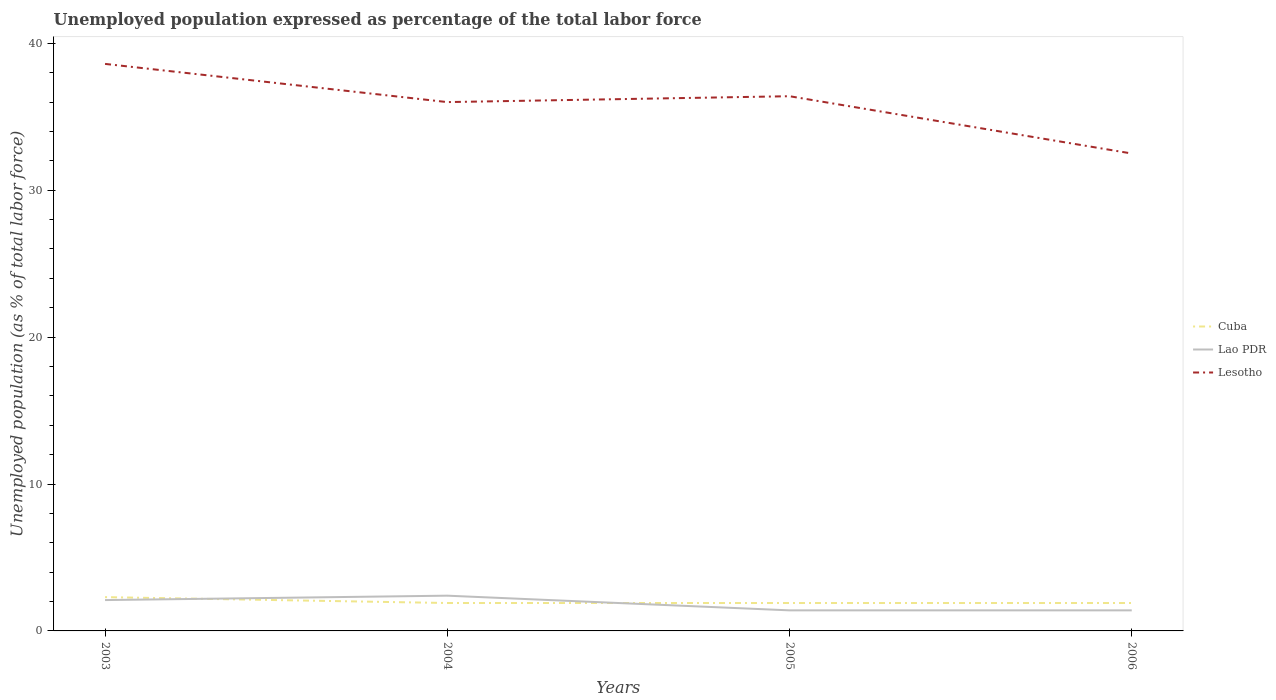Does the line corresponding to Lao PDR intersect with the line corresponding to Cuba?
Keep it short and to the point. Yes. Is the number of lines equal to the number of legend labels?
Offer a very short reply. Yes. Across all years, what is the maximum unemployment in in Cuba?
Offer a very short reply. 1.9. What is the total unemployment in in Cuba in the graph?
Provide a succinct answer. 0.4. What is the difference between the highest and the second highest unemployment in in Lao PDR?
Make the answer very short. 1. What is the difference between the highest and the lowest unemployment in in Cuba?
Provide a succinct answer. 1. What is the difference between two consecutive major ticks on the Y-axis?
Your answer should be compact. 10. Does the graph contain grids?
Your response must be concise. No. Where does the legend appear in the graph?
Offer a very short reply. Center right. What is the title of the graph?
Your answer should be compact. Unemployed population expressed as percentage of the total labor force. Does "Andorra" appear as one of the legend labels in the graph?
Your response must be concise. No. What is the label or title of the Y-axis?
Your answer should be very brief. Unemployed population (as % of total labor force). What is the Unemployed population (as % of total labor force) in Cuba in 2003?
Provide a succinct answer. 2.3. What is the Unemployed population (as % of total labor force) in Lao PDR in 2003?
Ensure brevity in your answer.  2.1. What is the Unemployed population (as % of total labor force) of Lesotho in 2003?
Make the answer very short. 38.6. What is the Unemployed population (as % of total labor force) of Cuba in 2004?
Provide a succinct answer. 1.9. What is the Unemployed population (as % of total labor force) of Lao PDR in 2004?
Make the answer very short. 2.4. What is the Unemployed population (as % of total labor force) in Lesotho in 2004?
Offer a terse response. 36. What is the Unemployed population (as % of total labor force) of Cuba in 2005?
Offer a terse response. 1.9. What is the Unemployed population (as % of total labor force) of Lao PDR in 2005?
Your response must be concise. 1.4. What is the Unemployed population (as % of total labor force) of Lesotho in 2005?
Offer a terse response. 36.4. What is the Unemployed population (as % of total labor force) in Cuba in 2006?
Your answer should be compact. 1.9. What is the Unemployed population (as % of total labor force) of Lao PDR in 2006?
Ensure brevity in your answer.  1.4. What is the Unemployed population (as % of total labor force) of Lesotho in 2006?
Keep it short and to the point. 32.5. Across all years, what is the maximum Unemployed population (as % of total labor force) in Cuba?
Offer a terse response. 2.3. Across all years, what is the maximum Unemployed population (as % of total labor force) in Lao PDR?
Ensure brevity in your answer.  2.4. Across all years, what is the maximum Unemployed population (as % of total labor force) of Lesotho?
Your answer should be very brief. 38.6. Across all years, what is the minimum Unemployed population (as % of total labor force) in Cuba?
Your answer should be very brief. 1.9. Across all years, what is the minimum Unemployed population (as % of total labor force) in Lao PDR?
Offer a very short reply. 1.4. Across all years, what is the minimum Unemployed population (as % of total labor force) in Lesotho?
Your response must be concise. 32.5. What is the total Unemployed population (as % of total labor force) of Cuba in the graph?
Give a very brief answer. 8. What is the total Unemployed population (as % of total labor force) of Lao PDR in the graph?
Give a very brief answer. 7.3. What is the total Unemployed population (as % of total labor force) in Lesotho in the graph?
Make the answer very short. 143.5. What is the difference between the Unemployed population (as % of total labor force) of Lao PDR in 2003 and that in 2005?
Your response must be concise. 0.7. What is the difference between the Unemployed population (as % of total labor force) in Lesotho in 2003 and that in 2006?
Keep it short and to the point. 6.1. What is the difference between the Unemployed population (as % of total labor force) of Cuba in 2004 and that in 2005?
Give a very brief answer. 0. What is the difference between the Unemployed population (as % of total labor force) of Cuba in 2004 and that in 2006?
Offer a terse response. 0. What is the difference between the Unemployed population (as % of total labor force) in Lao PDR in 2005 and that in 2006?
Offer a terse response. 0. What is the difference between the Unemployed population (as % of total labor force) of Lesotho in 2005 and that in 2006?
Your response must be concise. 3.9. What is the difference between the Unemployed population (as % of total labor force) of Cuba in 2003 and the Unemployed population (as % of total labor force) of Lao PDR in 2004?
Offer a very short reply. -0.1. What is the difference between the Unemployed population (as % of total labor force) of Cuba in 2003 and the Unemployed population (as % of total labor force) of Lesotho in 2004?
Provide a succinct answer. -33.7. What is the difference between the Unemployed population (as % of total labor force) in Lao PDR in 2003 and the Unemployed population (as % of total labor force) in Lesotho in 2004?
Ensure brevity in your answer.  -33.9. What is the difference between the Unemployed population (as % of total labor force) in Cuba in 2003 and the Unemployed population (as % of total labor force) in Lesotho in 2005?
Ensure brevity in your answer.  -34.1. What is the difference between the Unemployed population (as % of total labor force) in Lao PDR in 2003 and the Unemployed population (as % of total labor force) in Lesotho in 2005?
Offer a very short reply. -34.3. What is the difference between the Unemployed population (as % of total labor force) of Cuba in 2003 and the Unemployed population (as % of total labor force) of Lao PDR in 2006?
Provide a succinct answer. 0.9. What is the difference between the Unemployed population (as % of total labor force) in Cuba in 2003 and the Unemployed population (as % of total labor force) in Lesotho in 2006?
Your answer should be compact. -30.2. What is the difference between the Unemployed population (as % of total labor force) of Lao PDR in 2003 and the Unemployed population (as % of total labor force) of Lesotho in 2006?
Offer a very short reply. -30.4. What is the difference between the Unemployed population (as % of total labor force) of Cuba in 2004 and the Unemployed population (as % of total labor force) of Lao PDR in 2005?
Provide a short and direct response. 0.5. What is the difference between the Unemployed population (as % of total labor force) of Cuba in 2004 and the Unemployed population (as % of total labor force) of Lesotho in 2005?
Your answer should be compact. -34.5. What is the difference between the Unemployed population (as % of total labor force) of Lao PDR in 2004 and the Unemployed population (as % of total labor force) of Lesotho in 2005?
Your response must be concise. -34. What is the difference between the Unemployed population (as % of total labor force) in Cuba in 2004 and the Unemployed population (as % of total labor force) in Lesotho in 2006?
Ensure brevity in your answer.  -30.6. What is the difference between the Unemployed population (as % of total labor force) of Lao PDR in 2004 and the Unemployed population (as % of total labor force) of Lesotho in 2006?
Provide a succinct answer. -30.1. What is the difference between the Unemployed population (as % of total labor force) of Cuba in 2005 and the Unemployed population (as % of total labor force) of Lao PDR in 2006?
Your response must be concise. 0.5. What is the difference between the Unemployed population (as % of total labor force) of Cuba in 2005 and the Unemployed population (as % of total labor force) of Lesotho in 2006?
Give a very brief answer. -30.6. What is the difference between the Unemployed population (as % of total labor force) of Lao PDR in 2005 and the Unemployed population (as % of total labor force) of Lesotho in 2006?
Provide a succinct answer. -31.1. What is the average Unemployed population (as % of total labor force) in Lao PDR per year?
Provide a succinct answer. 1.82. What is the average Unemployed population (as % of total labor force) of Lesotho per year?
Offer a terse response. 35.88. In the year 2003, what is the difference between the Unemployed population (as % of total labor force) of Cuba and Unemployed population (as % of total labor force) of Lesotho?
Offer a very short reply. -36.3. In the year 2003, what is the difference between the Unemployed population (as % of total labor force) in Lao PDR and Unemployed population (as % of total labor force) in Lesotho?
Provide a short and direct response. -36.5. In the year 2004, what is the difference between the Unemployed population (as % of total labor force) of Cuba and Unemployed population (as % of total labor force) of Lao PDR?
Give a very brief answer. -0.5. In the year 2004, what is the difference between the Unemployed population (as % of total labor force) of Cuba and Unemployed population (as % of total labor force) of Lesotho?
Your answer should be compact. -34.1. In the year 2004, what is the difference between the Unemployed population (as % of total labor force) of Lao PDR and Unemployed population (as % of total labor force) of Lesotho?
Offer a very short reply. -33.6. In the year 2005, what is the difference between the Unemployed population (as % of total labor force) in Cuba and Unemployed population (as % of total labor force) in Lao PDR?
Provide a succinct answer. 0.5. In the year 2005, what is the difference between the Unemployed population (as % of total labor force) of Cuba and Unemployed population (as % of total labor force) of Lesotho?
Offer a very short reply. -34.5. In the year 2005, what is the difference between the Unemployed population (as % of total labor force) of Lao PDR and Unemployed population (as % of total labor force) of Lesotho?
Your response must be concise. -35. In the year 2006, what is the difference between the Unemployed population (as % of total labor force) in Cuba and Unemployed population (as % of total labor force) in Lesotho?
Provide a succinct answer. -30.6. In the year 2006, what is the difference between the Unemployed population (as % of total labor force) in Lao PDR and Unemployed population (as % of total labor force) in Lesotho?
Your answer should be very brief. -31.1. What is the ratio of the Unemployed population (as % of total labor force) of Cuba in 2003 to that in 2004?
Your answer should be very brief. 1.21. What is the ratio of the Unemployed population (as % of total labor force) of Lao PDR in 2003 to that in 2004?
Give a very brief answer. 0.88. What is the ratio of the Unemployed population (as % of total labor force) of Lesotho in 2003 to that in 2004?
Ensure brevity in your answer.  1.07. What is the ratio of the Unemployed population (as % of total labor force) in Cuba in 2003 to that in 2005?
Your response must be concise. 1.21. What is the ratio of the Unemployed population (as % of total labor force) in Lesotho in 2003 to that in 2005?
Provide a short and direct response. 1.06. What is the ratio of the Unemployed population (as % of total labor force) of Cuba in 2003 to that in 2006?
Offer a terse response. 1.21. What is the ratio of the Unemployed population (as % of total labor force) of Lao PDR in 2003 to that in 2006?
Keep it short and to the point. 1.5. What is the ratio of the Unemployed population (as % of total labor force) of Lesotho in 2003 to that in 2006?
Your response must be concise. 1.19. What is the ratio of the Unemployed population (as % of total labor force) in Lao PDR in 2004 to that in 2005?
Your answer should be compact. 1.71. What is the ratio of the Unemployed population (as % of total labor force) in Lao PDR in 2004 to that in 2006?
Offer a very short reply. 1.71. What is the ratio of the Unemployed population (as % of total labor force) of Lesotho in 2004 to that in 2006?
Offer a terse response. 1.11. What is the ratio of the Unemployed population (as % of total labor force) in Cuba in 2005 to that in 2006?
Provide a succinct answer. 1. What is the ratio of the Unemployed population (as % of total labor force) of Lao PDR in 2005 to that in 2006?
Offer a terse response. 1. What is the ratio of the Unemployed population (as % of total labor force) in Lesotho in 2005 to that in 2006?
Your response must be concise. 1.12. What is the difference between the highest and the second highest Unemployed population (as % of total labor force) in Cuba?
Make the answer very short. 0.4. What is the difference between the highest and the lowest Unemployed population (as % of total labor force) of Lao PDR?
Offer a terse response. 1. What is the difference between the highest and the lowest Unemployed population (as % of total labor force) of Lesotho?
Your answer should be compact. 6.1. 